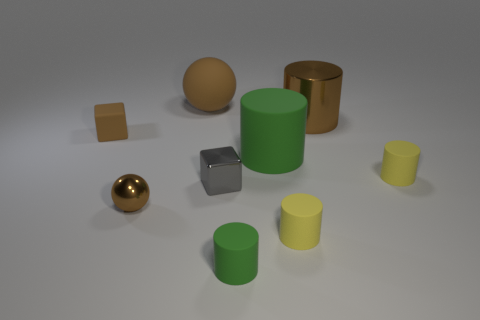Subtract all big brown cylinders. How many cylinders are left? 4 Add 1 big brown matte balls. How many objects exist? 10 Subtract all yellow cylinders. How many cylinders are left? 3 Subtract all yellow cubes. How many yellow cylinders are left? 2 Add 6 large cyan matte things. How many large cyan matte things exist? 6 Subtract 0 red spheres. How many objects are left? 9 Subtract all cylinders. How many objects are left? 4 Subtract 2 blocks. How many blocks are left? 0 Subtract all purple cubes. Subtract all green cylinders. How many cubes are left? 2 Subtract all tiny yellow rubber things. Subtract all big green things. How many objects are left? 6 